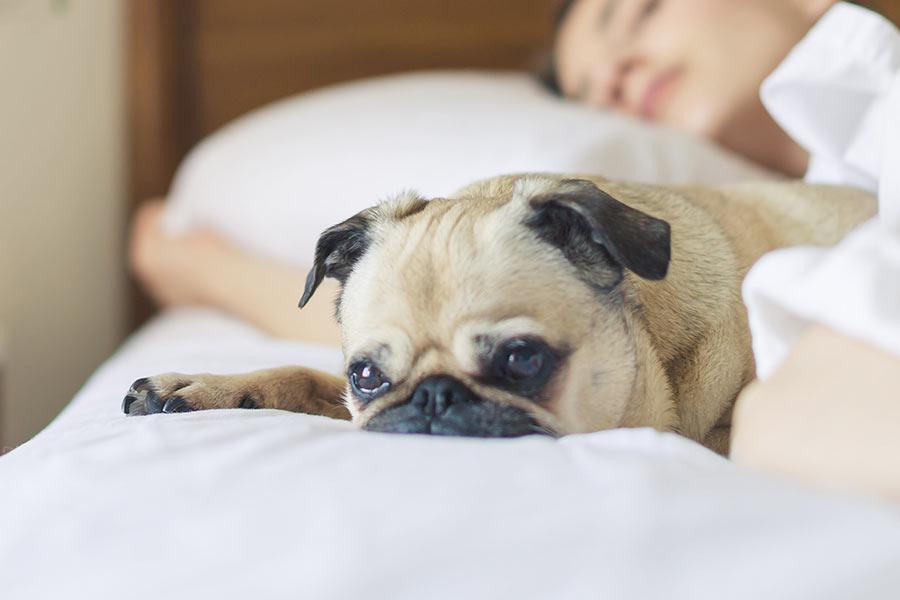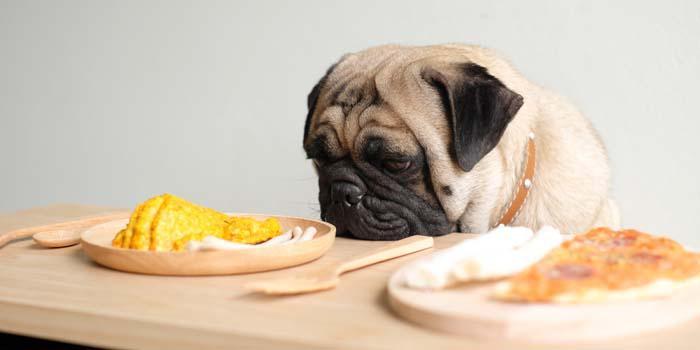The first image is the image on the left, the second image is the image on the right. Examine the images to the left and right. Is the description "The left image shows a pug with something edible in front of him, and the right image shows a pug in a collared shirt with a bowl in front of him." accurate? Answer yes or no. No. The first image is the image on the left, the second image is the image on the right. Considering the images on both sides, is "A dog has a white dish in front of him." valid? Answer yes or no. No. 